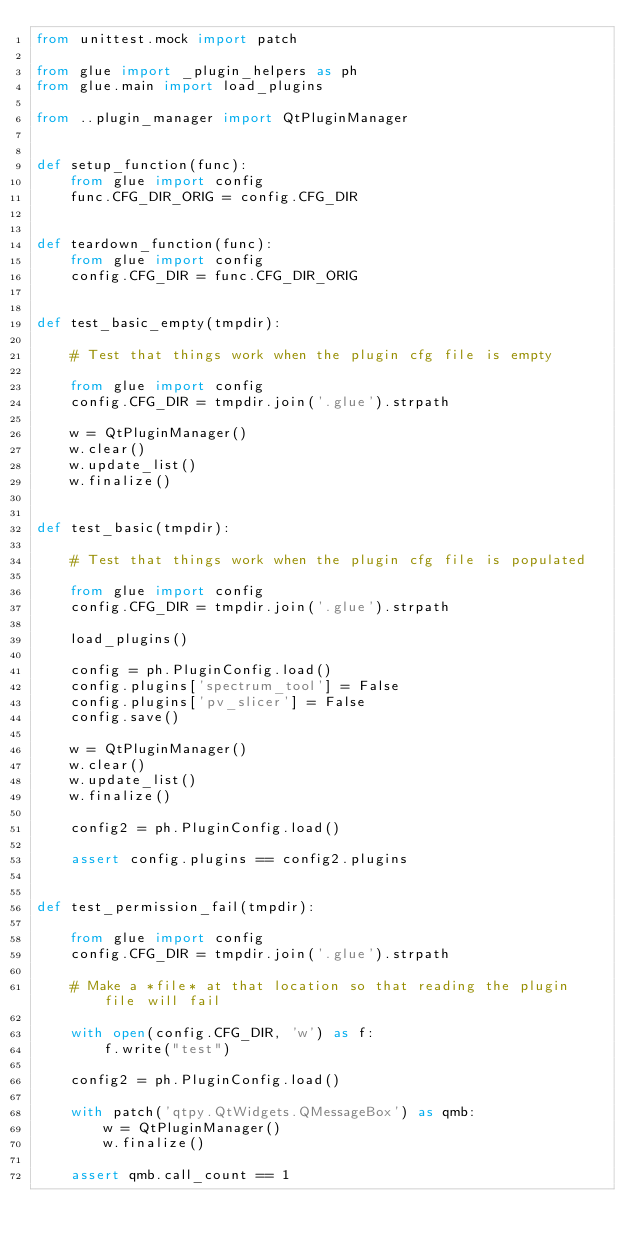<code> <loc_0><loc_0><loc_500><loc_500><_Python_>from unittest.mock import patch

from glue import _plugin_helpers as ph
from glue.main import load_plugins

from ..plugin_manager import QtPluginManager


def setup_function(func):
    from glue import config
    func.CFG_DIR_ORIG = config.CFG_DIR


def teardown_function(func):
    from glue import config
    config.CFG_DIR = func.CFG_DIR_ORIG


def test_basic_empty(tmpdir):

    # Test that things work when the plugin cfg file is empty

    from glue import config
    config.CFG_DIR = tmpdir.join('.glue').strpath

    w = QtPluginManager()
    w.clear()
    w.update_list()
    w.finalize()


def test_basic(tmpdir):

    # Test that things work when the plugin cfg file is populated

    from glue import config
    config.CFG_DIR = tmpdir.join('.glue').strpath

    load_plugins()

    config = ph.PluginConfig.load()
    config.plugins['spectrum_tool'] = False
    config.plugins['pv_slicer'] = False
    config.save()

    w = QtPluginManager()
    w.clear()
    w.update_list()
    w.finalize()

    config2 = ph.PluginConfig.load()

    assert config.plugins == config2.plugins


def test_permission_fail(tmpdir):

    from glue import config
    config.CFG_DIR = tmpdir.join('.glue').strpath

    # Make a *file* at that location so that reading the plugin file will fail

    with open(config.CFG_DIR, 'w') as f:
        f.write("test")

    config2 = ph.PluginConfig.load()

    with patch('qtpy.QtWidgets.QMessageBox') as qmb:
        w = QtPluginManager()
        w.finalize()

    assert qmb.call_count == 1
</code> 